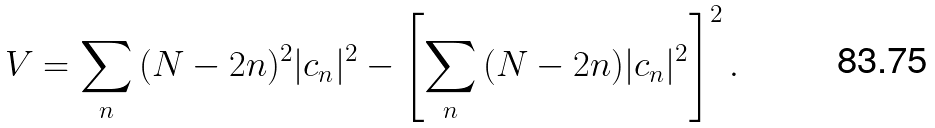<formula> <loc_0><loc_0><loc_500><loc_500>V = \sum _ { n } { ( N - 2 n ) ^ { 2 } | c _ { n } | ^ { 2 } } - \left [ \sum _ { n } { ( N - 2 n ) | c _ { n } | ^ { 2 } } \right ] ^ { 2 } .</formula> 